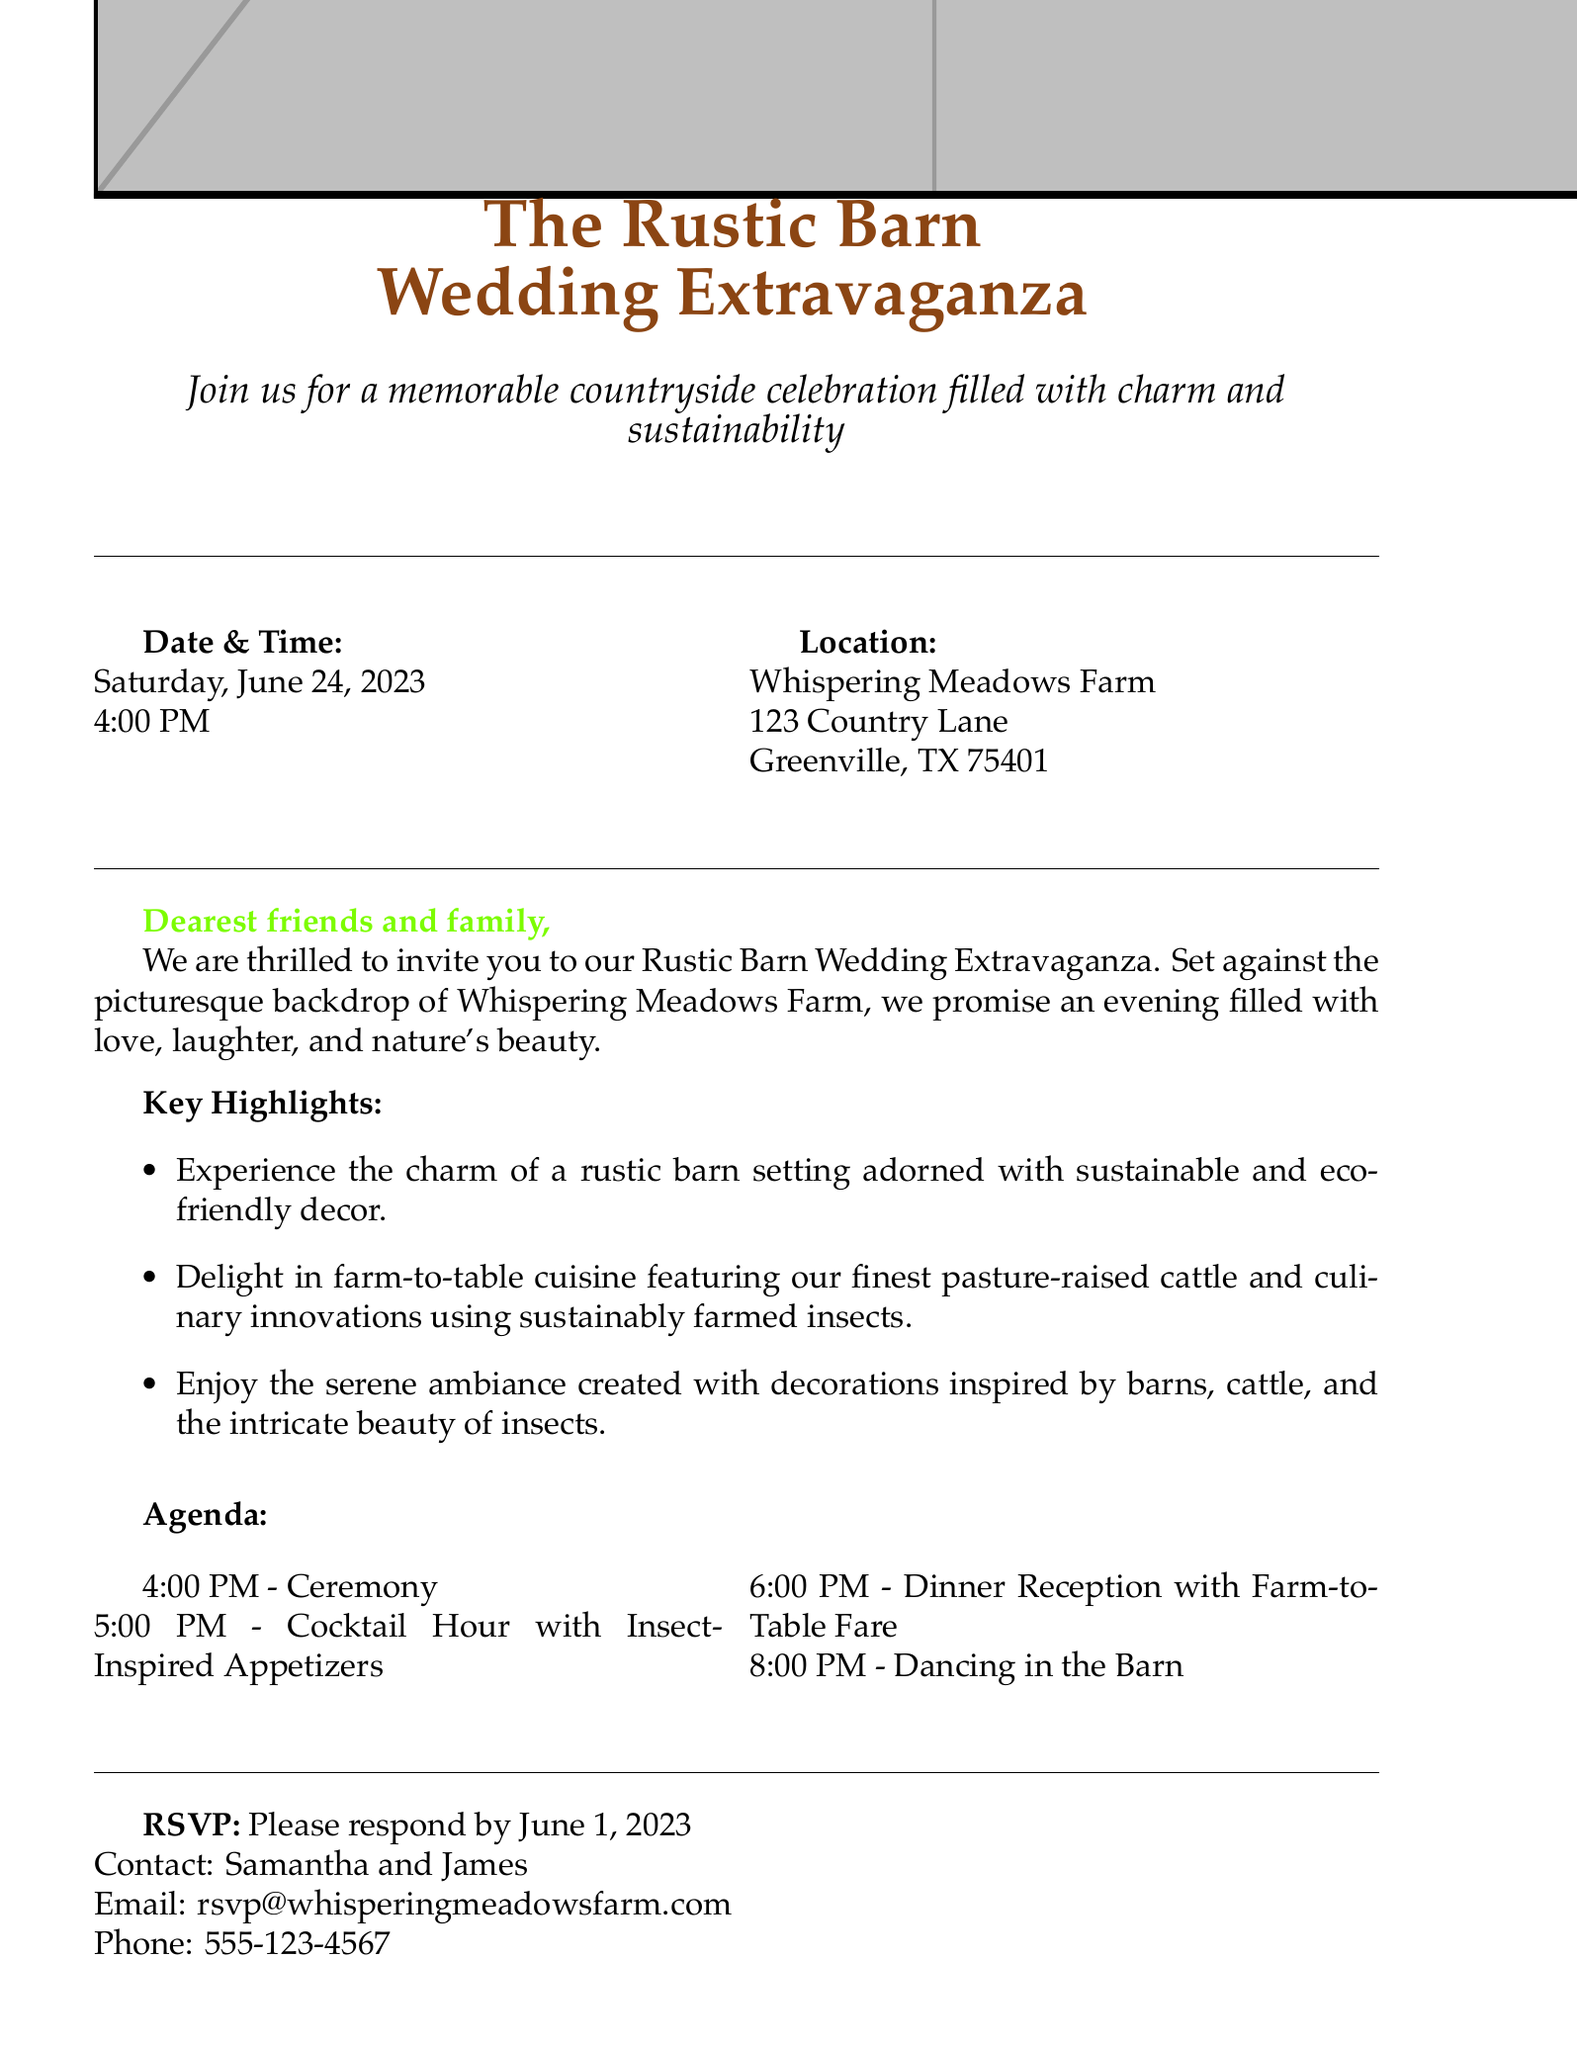What is the date of the wedding? The date of the wedding is clearly stated in the invitation as Saturday, June 24, 2023.
Answer: June 24, 2023 What time does the ceremony start? The ceremony time is mentioned in the agenda section of the invitation.
Answer: 4:00 PM Where is the wedding located? The location of the wedding is provided in the invitation under the location section.
Answer: Whispering Meadows Farm What is the dress code for the event? The dress code is specified in the additional information section of the invitation.
Answer: Rustic Chic What type of cuisine will be served? The cuisine type is highlighted in the key highlights, indicating the use of farm-to-table ingredients.
Answer: Farm-to-table cuisine What are insect-inspired appetizers? The mention of insect-inspired appetizers during the cocktail hour is uniquely stated in the agenda.
Answer: Insect-Inspired Appetizers What is the RSVP deadline? The RSVP deadline is given specifically in the invitation details.
Answer: June 1, 2023 Who are the hosts of the wedding? The names of the hosts are presented at the end of the invitation in a personal message.
Answer: Samantha & James What will guest activities include? Guest activities are outlined in the agenda section with a sequence of events for the evening.
Answer: Ceremony, Cocktail Hour, Dinner Reception, Dancing 